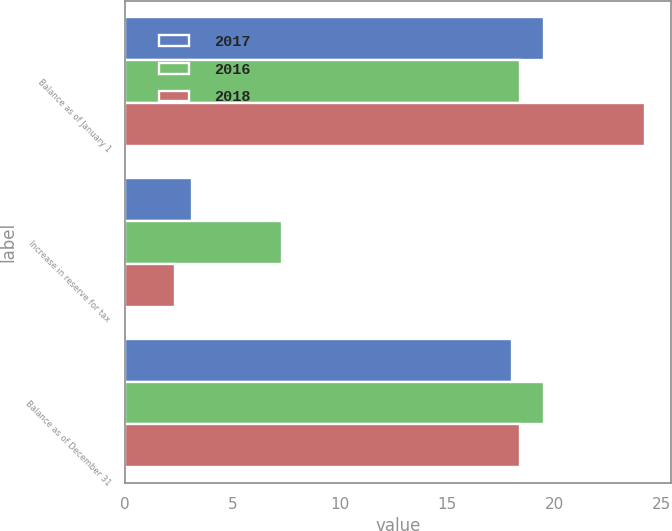<chart> <loc_0><loc_0><loc_500><loc_500><stacked_bar_chart><ecel><fcel>Balance as of January 1<fcel>Increase in reserve for tax<fcel>Balance as of December 31<nl><fcel>2017<fcel>19.5<fcel>3.1<fcel>18<nl><fcel>2016<fcel>18.4<fcel>7.3<fcel>19.5<nl><fcel>2018<fcel>24.2<fcel>2.3<fcel>18.4<nl></chart> 